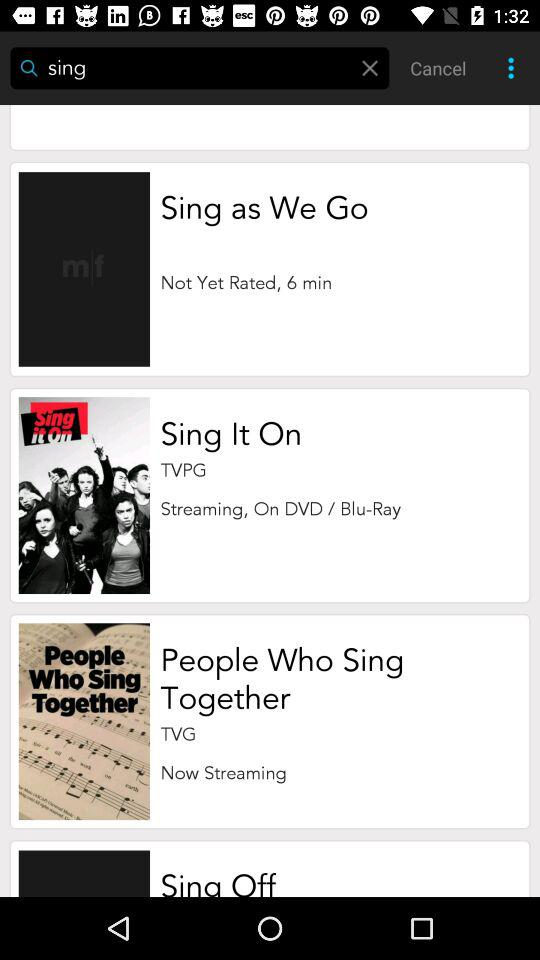What is the duration of "Sing as We Go"? The duration is 6 minutes. 